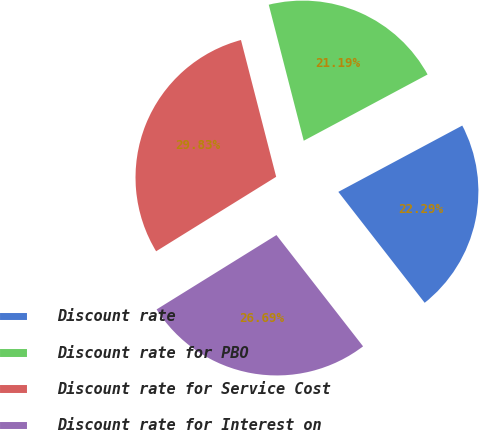Convert chart. <chart><loc_0><loc_0><loc_500><loc_500><pie_chart><fcel>Discount rate<fcel>Discount rate for PBO<fcel>Discount rate for Service Cost<fcel>Discount rate for Interest on<nl><fcel>22.29%<fcel>21.19%<fcel>29.83%<fcel>26.69%<nl></chart> 